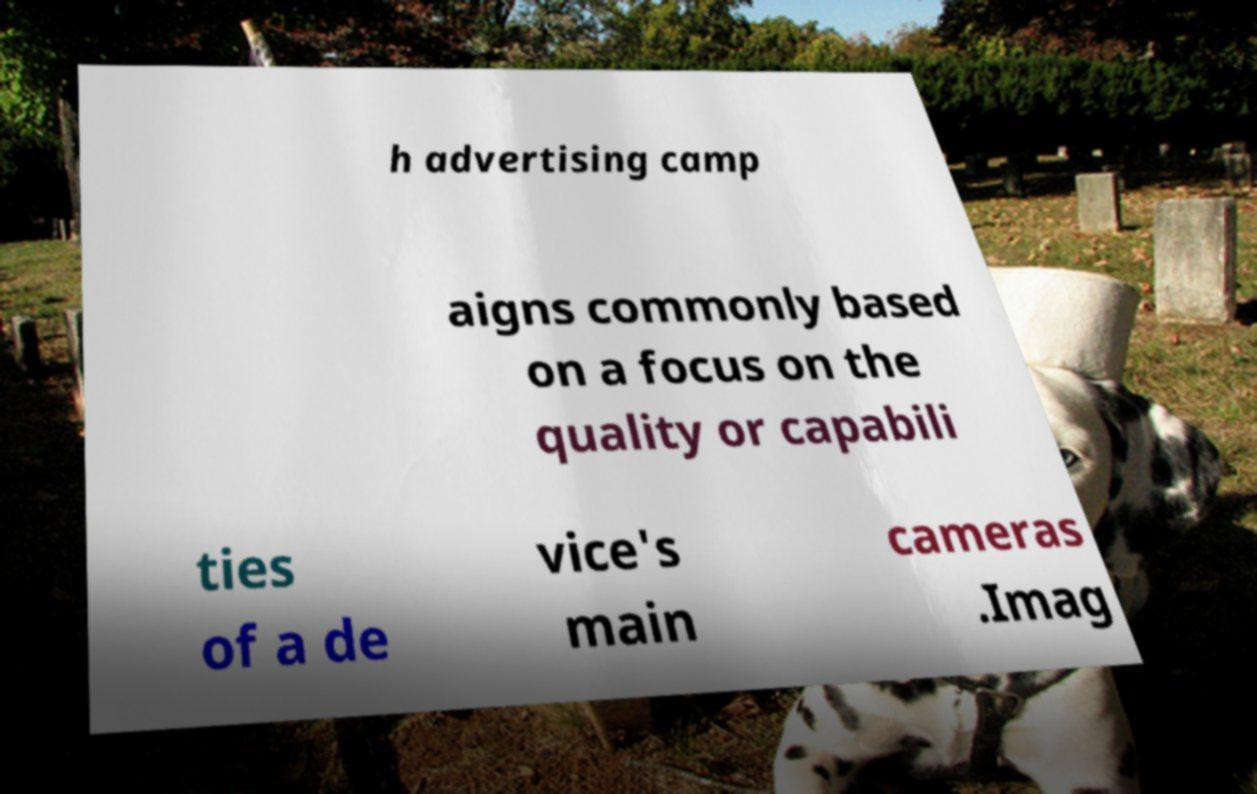I need the written content from this picture converted into text. Can you do that? h advertising camp aigns commonly based on a focus on the quality or capabili ties of a de vice's main cameras .Imag 